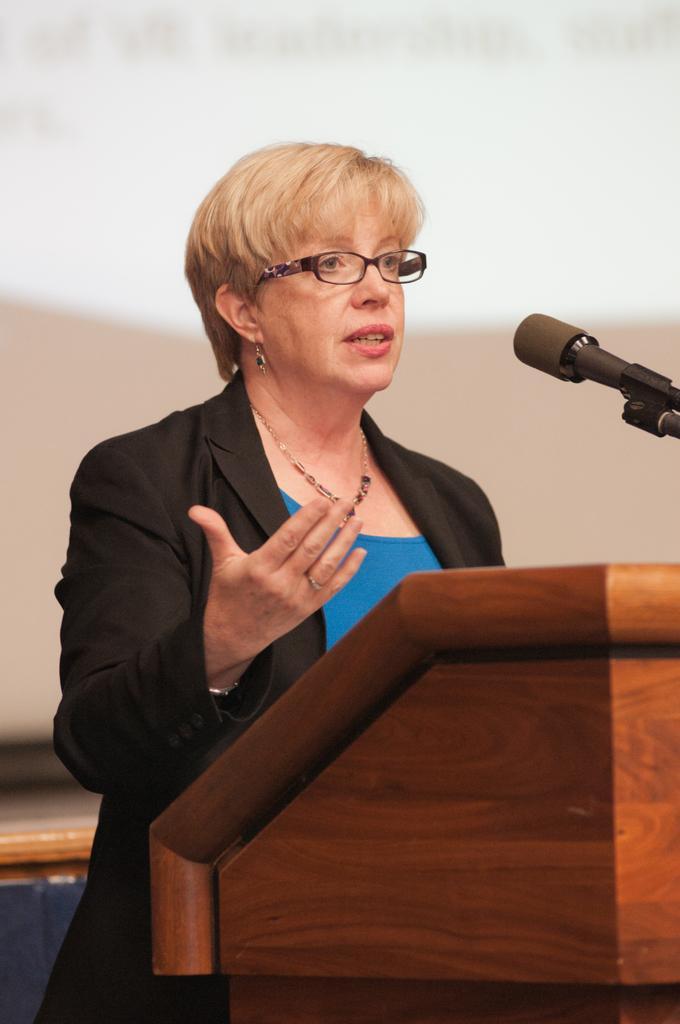How would you summarize this image in a sentence or two? In this image I can see a person standing wearing black blazer, blue color shirt, in front I can see a podium and microphone. Background is in white color. 